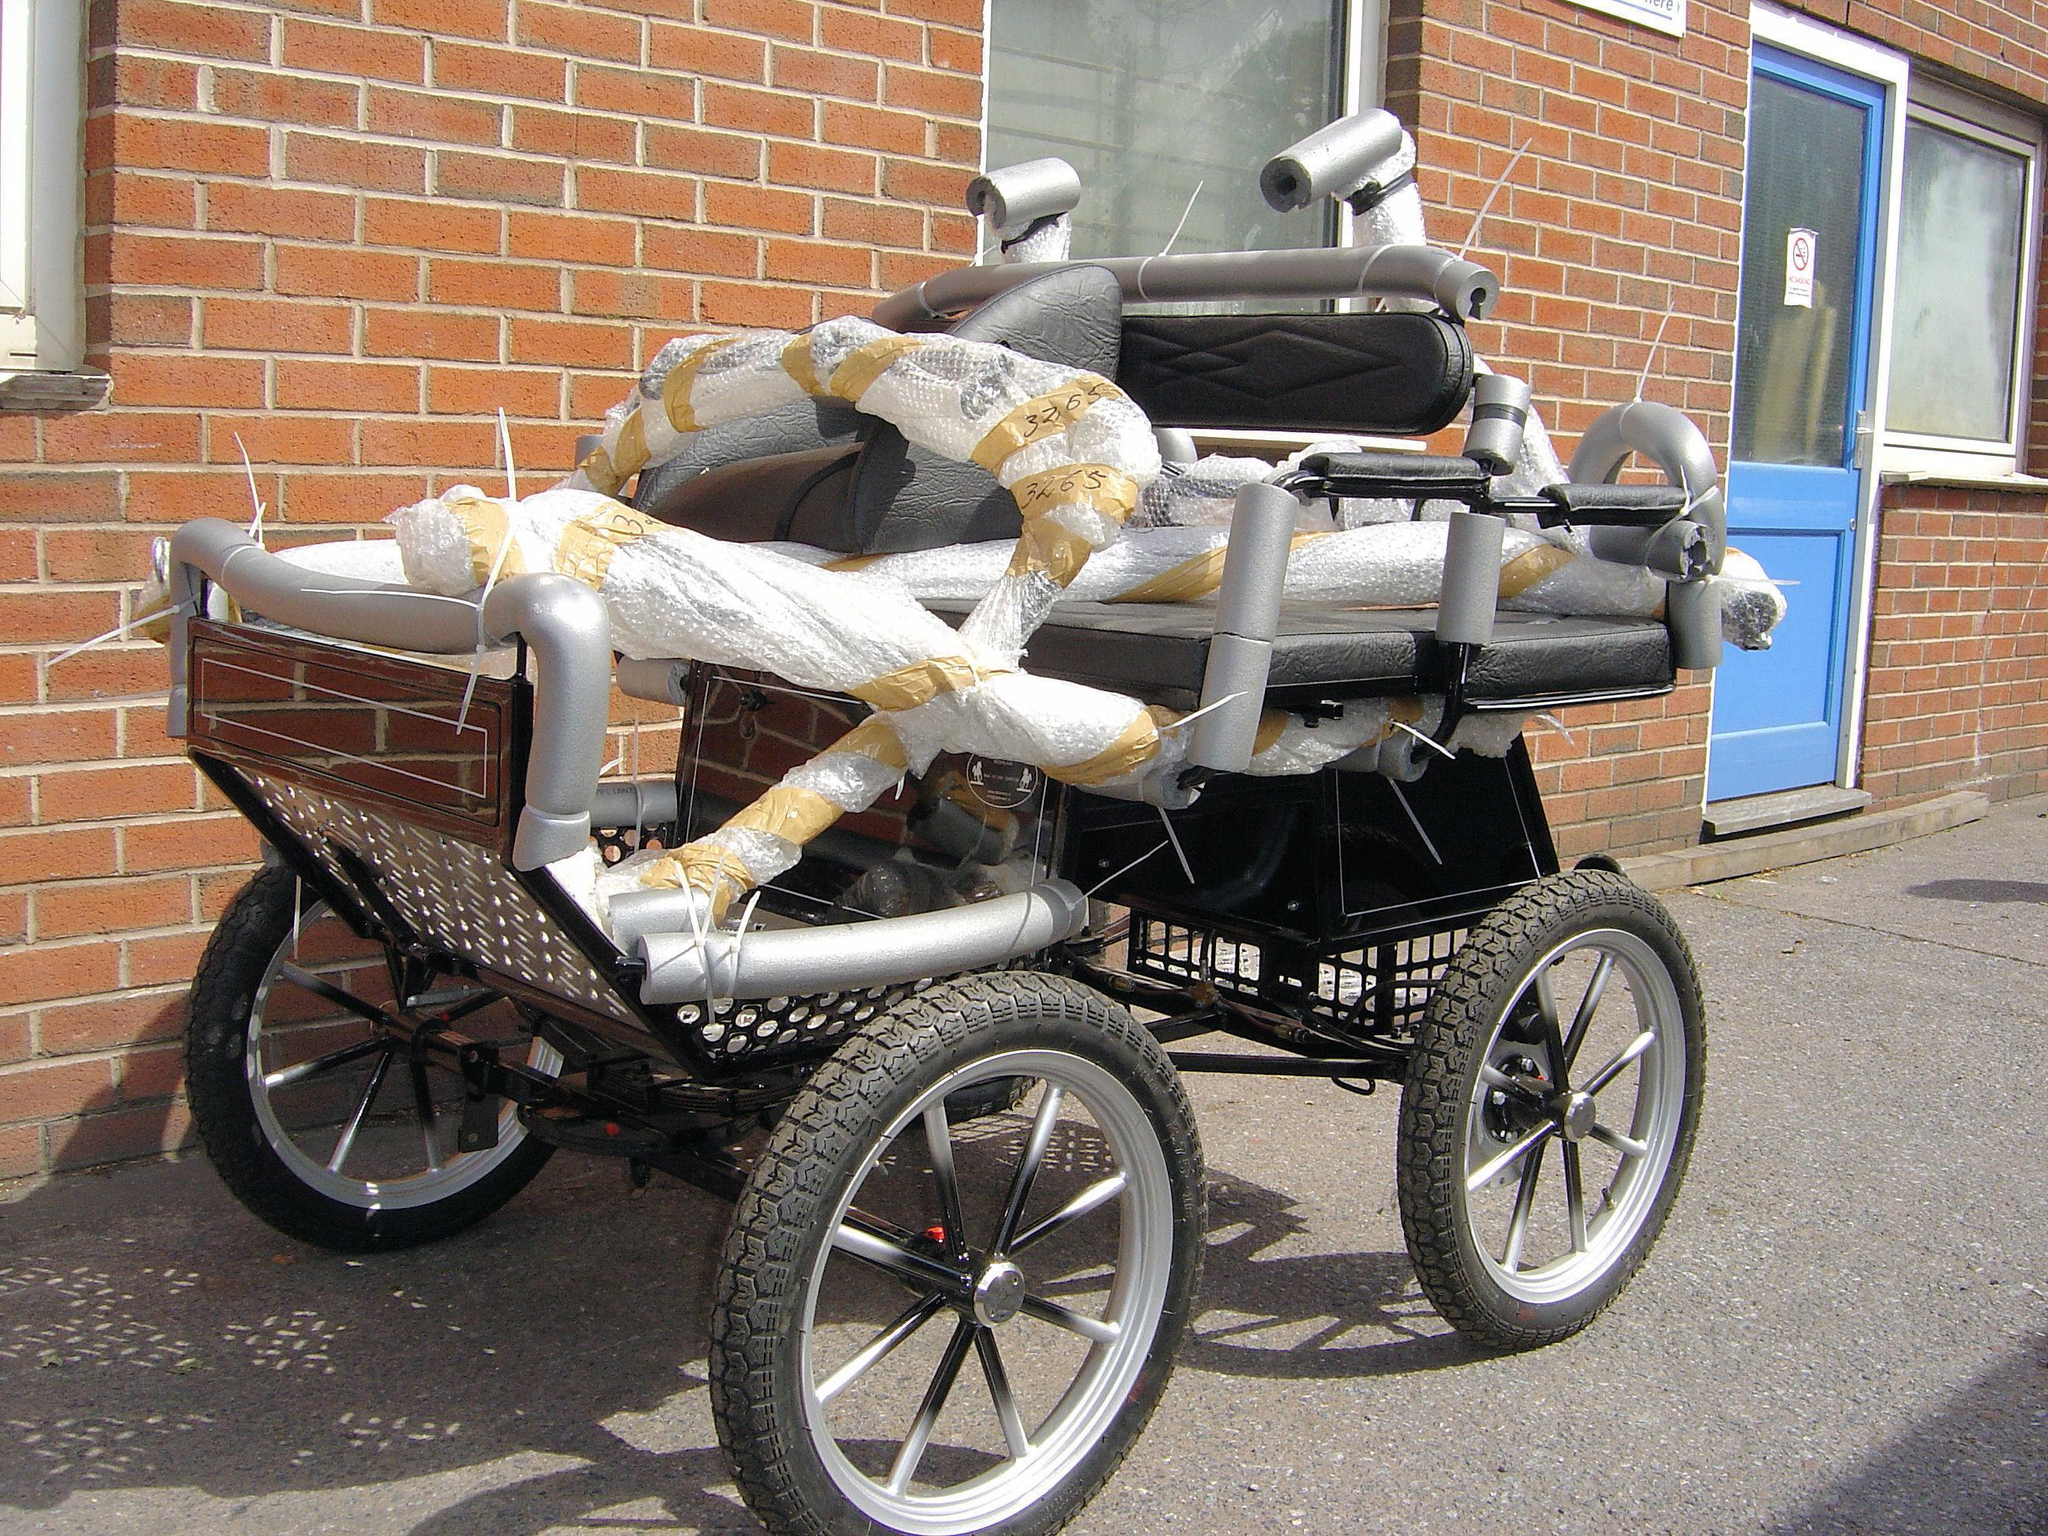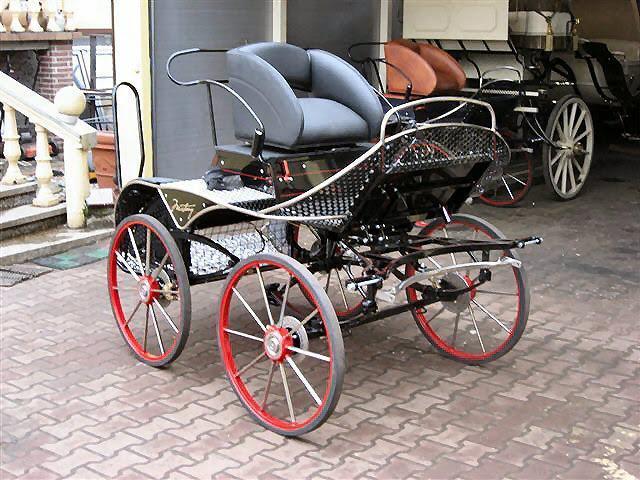The first image is the image on the left, the second image is the image on the right. For the images displayed, is the sentence "An image shows a buggy with treaded rubber tires." factually correct? Answer yes or no. Yes. 